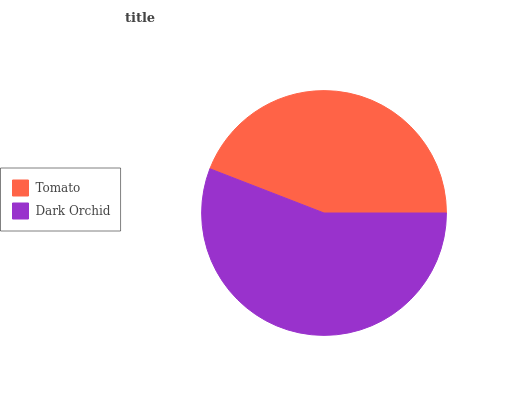Is Tomato the minimum?
Answer yes or no. Yes. Is Dark Orchid the maximum?
Answer yes or no. Yes. Is Dark Orchid the minimum?
Answer yes or no. No. Is Dark Orchid greater than Tomato?
Answer yes or no. Yes. Is Tomato less than Dark Orchid?
Answer yes or no. Yes. Is Tomato greater than Dark Orchid?
Answer yes or no. No. Is Dark Orchid less than Tomato?
Answer yes or no. No. Is Dark Orchid the high median?
Answer yes or no. Yes. Is Tomato the low median?
Answer yes or no. Yes. Is Tomato the high median?
Answer yes or no. No. Is Dark Orchid the low median?
Answer yes or no. No. 